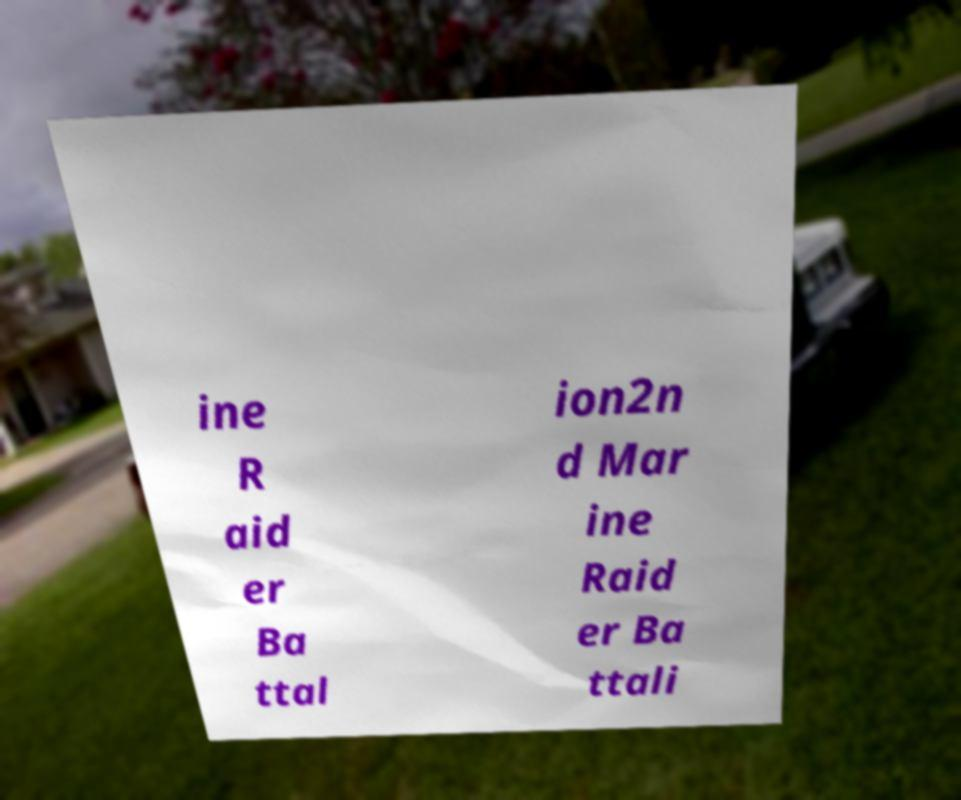Could you extract and type out the text from this image? ine R aid er Ba ttal ion2n d Mar ine Raid er Ba ttali 